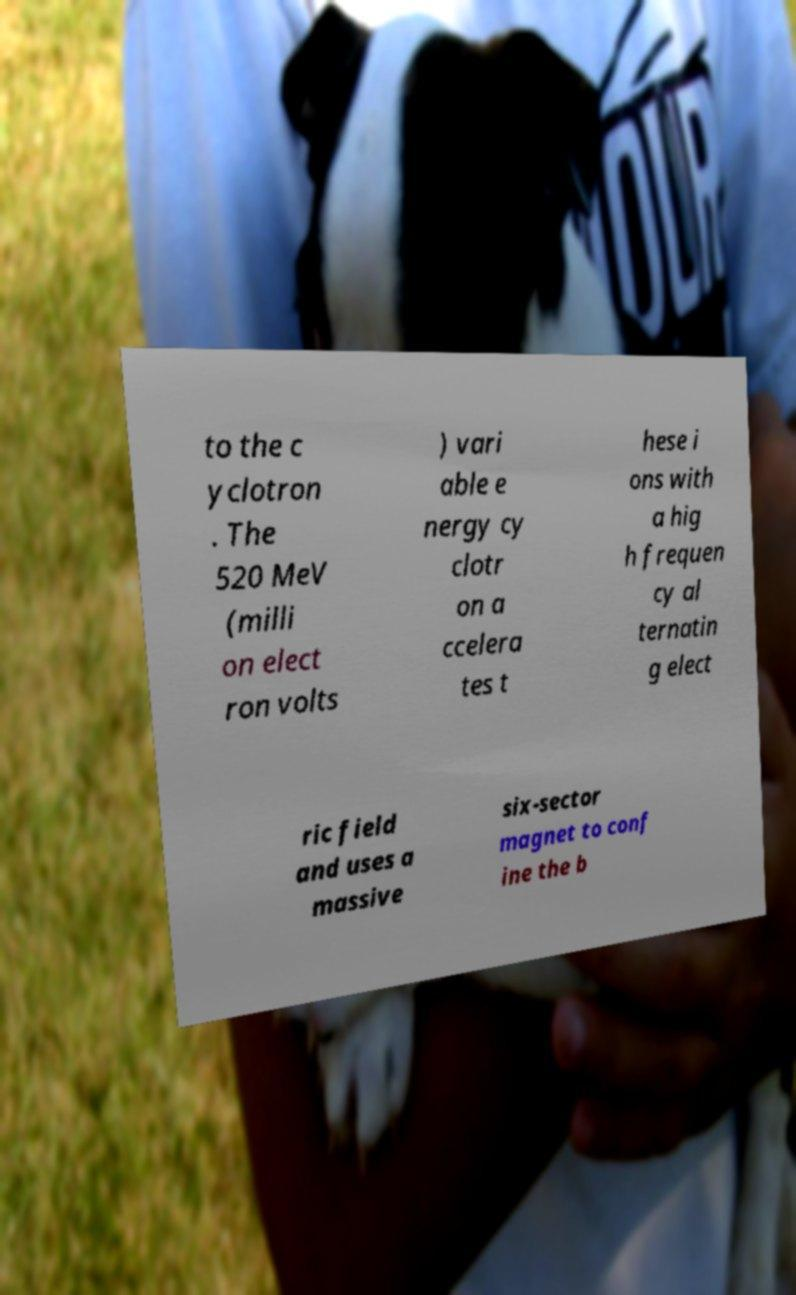Can you read and provide the text displayed in the image?This photo seems to have some interesting text. Can you extract and type it out for me? to the c yclotron . The 520 MeV (milli on elect ron volts ) vari able e nergy cy clotr on a ccelera tes t hese i ons with a hig h frequen cy al ternatin g elect ric field and uses a massive six-sector magnet to conf ine the b 